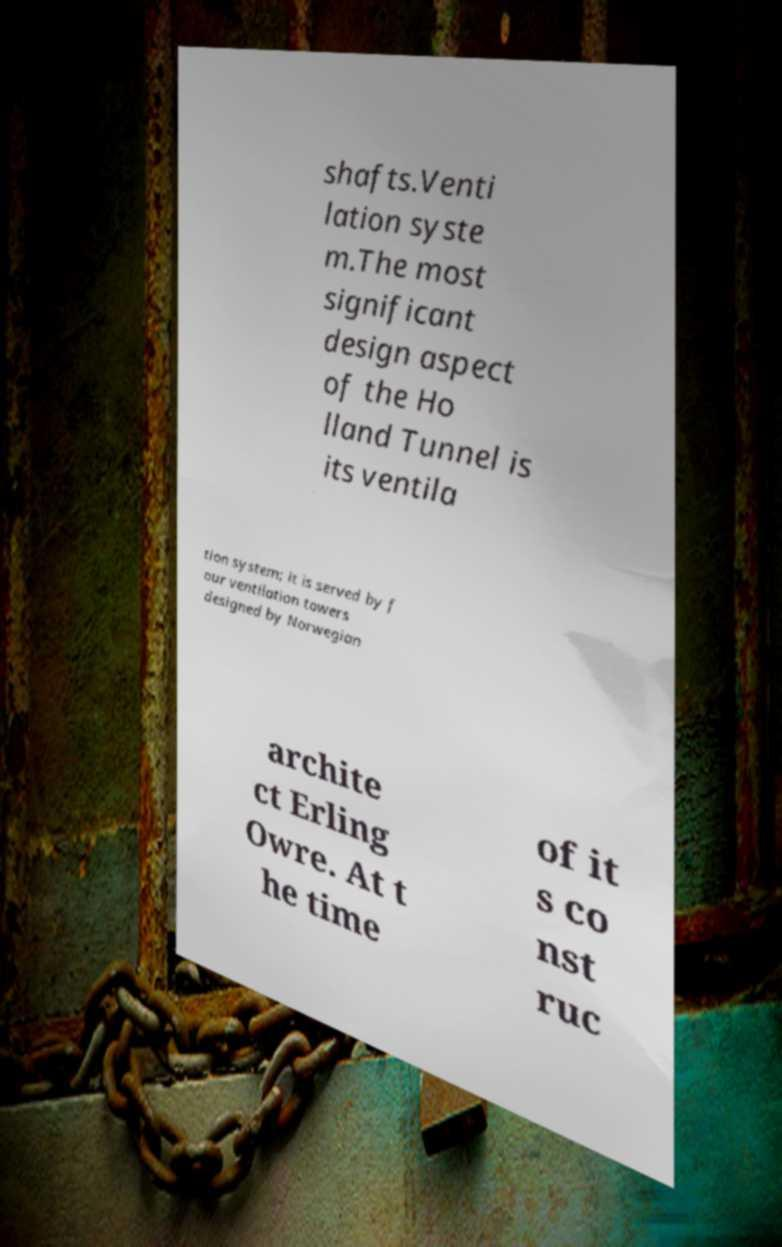I need the written content from this picture converted into text. Can you do that? shafts.Venti lation syste m.The most significant design aspect of the Ho lland Tunnel is its ventila tion system; it is served by f our ventilation towers designed by Norwegian archite ct Erling Owre. At t he time of it s co nst ruc 